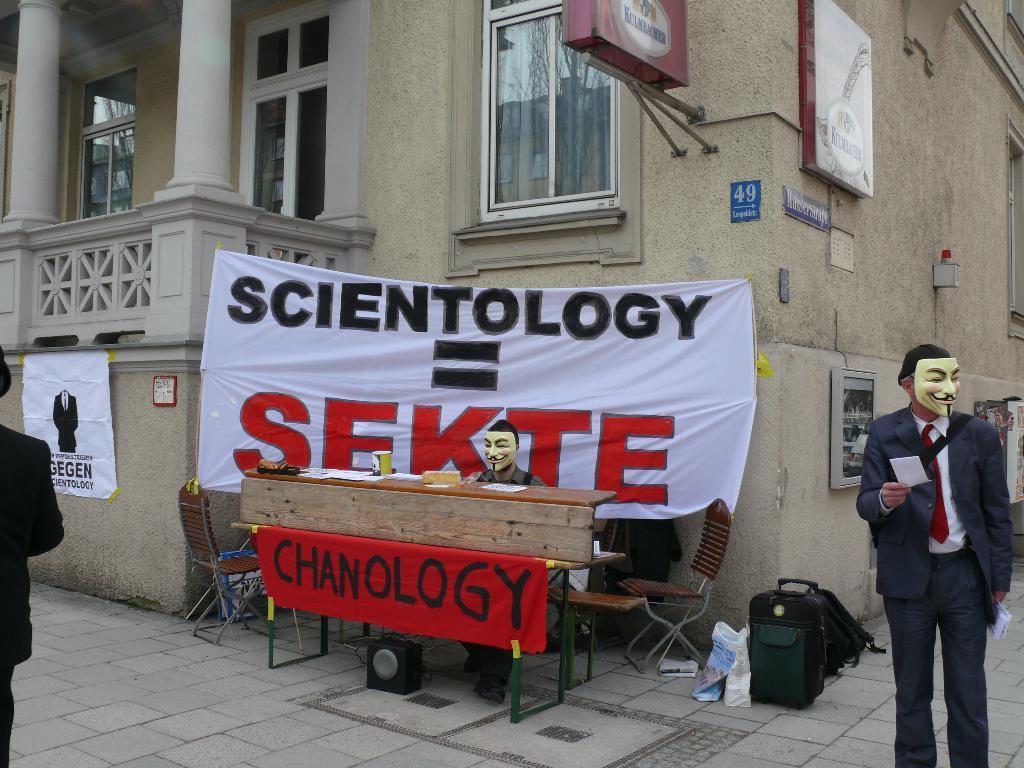Describe this image in one or two sentences. On the right side of the image we can see a man standing by wearing a mask on his face. In the center of the image we can see a man wearing a mask is sitting on the desk. There is a banner, chairs, bags on the ground. In the background of the image we can see a building. 